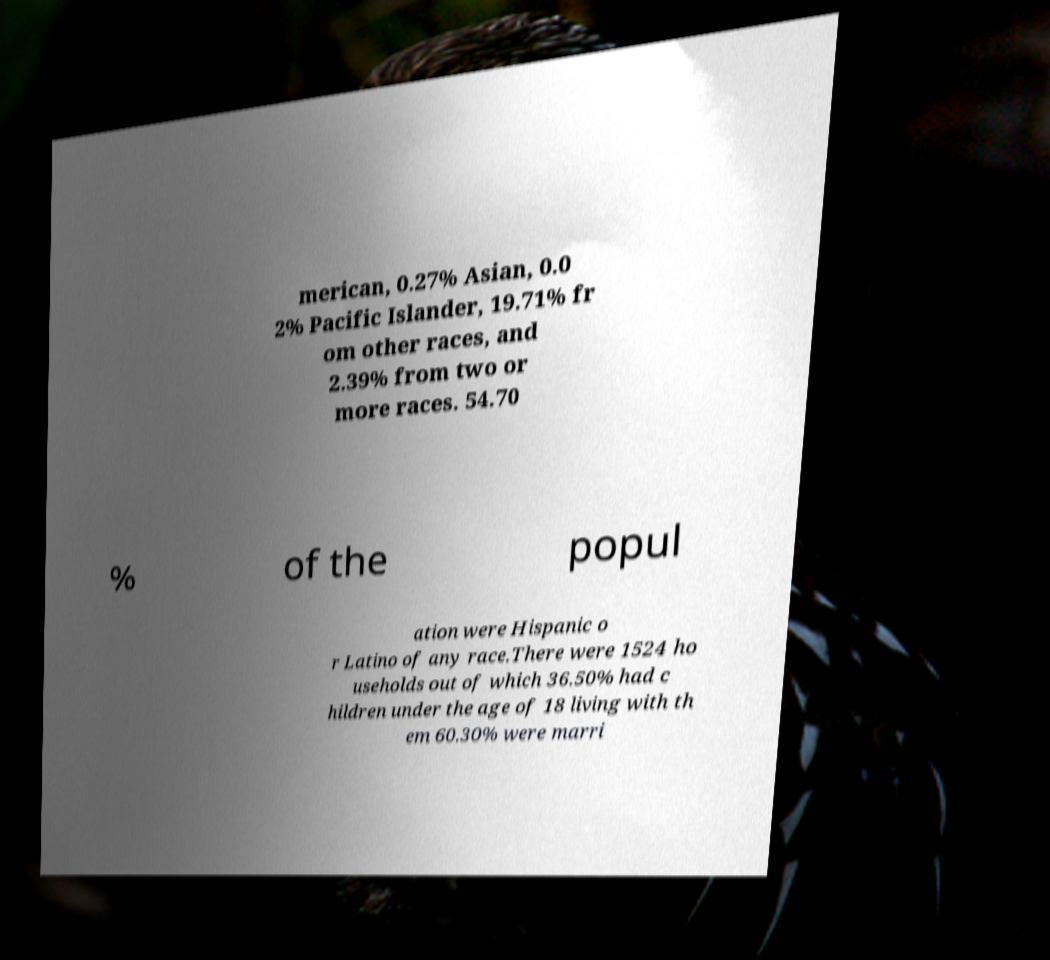What messages or text are displayed in this image? I need them in a readable, typed format. merican, 0.27% Asian, 0.0 2% Pacific Islander, 19.71% fr om other races, and 2.39% from two or more races. 54.70 % of the popul ation were Hispanic o r Latino of any race.There were 1524 ho useholds out of which 36.50% had c hildren under the age of 18 living with th em 60.30% were marri 